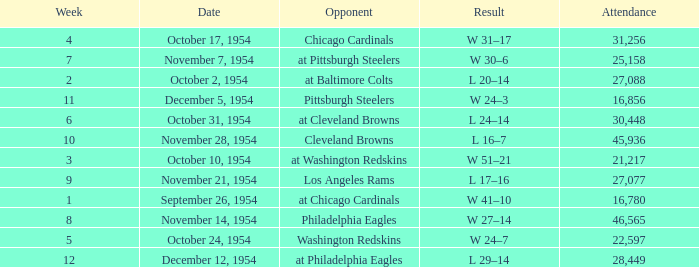How many weeks have october 31, 1954 as the date? 1.0. 